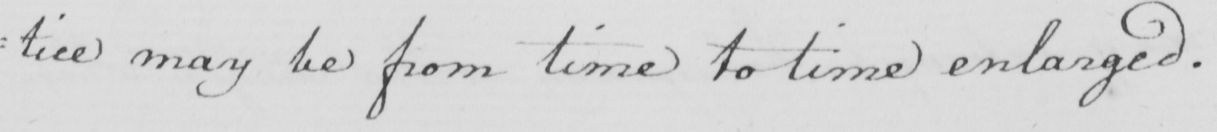What does this handwritten line say? : tice may be from time to time enlarged . 